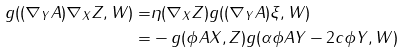<formula> <loc_0><loc_0><loc_500><loc_500>g ( ( \nabla _ { Y } A ) \nabla _ { X } Z , W ) = & \eta ( \nabla _ { X } Z ) g ( ( \nabla _ { Y } A ) \xi , W ) \\ = & - g ( \phi A X , Z ) g ( \alpha \phi A Y - 2 c \phi Y , W )</formula> 